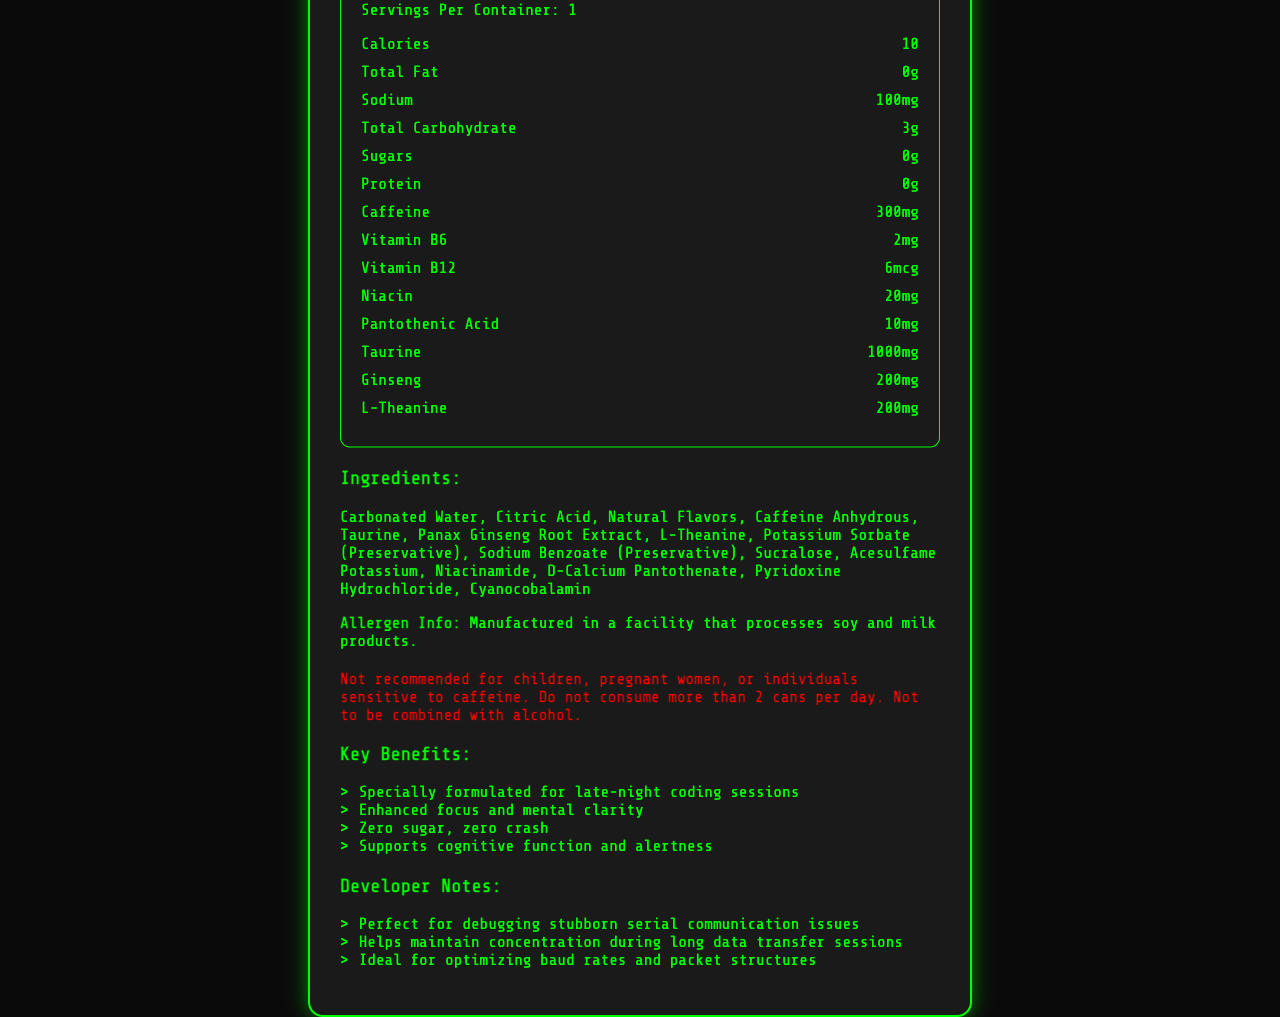what is the serving size for CodeBlast Extreme? The serving size is explicitly mentioned as "16 fl oz (473 mL)" in the document under Nutrition Facts.
Answer: 16 fl oz (473 mL) how many calories are there per serving? The document lists "Calories" as 10 per serving in the Nutrition Facts section.
Answer: 10 How much caffeine does one serving of CodeBlast Extreme contain? The document indicates that each serving contains 300mg of caffeine.
Answer: 300mg what are the ingredients listed in CodeBlast Extreme? The document includes a section titled "Ingredients" which lists all the ingredients.
Answer: Carbonated Water, Citric Acid, Natural Flavors, Caffeine Anhydrous, Taurine, Panax Ginseng Root Extract, L-Theanine, Potassium Sorbate (Preservative), Sodium Benzoate (Preservative), Sucralose, Acesulfame Potassium, Niacinamide, D-Calcium Pantothenate, Pyridoxine Hydrochloride, Cyanocobalamin what is the warning statement on the CodeBlast Extreme label? The warning statement is clearly mentioned towards the end of the document.
Answer: Not recommended for children, pregnant women, or individuals sensitive to caffeine. Do not consume more than 2 cans per day. Not to be combined with alcohol which vitamin is present in the highest amount in CodeBlast Extreme? 
A. Vitamin B6
B. Vitamin B12
C. Niacin
D. Pantothenic Acid The document lists Niacin at 20mg, which is more than the amounts of Vitamin B6 (2mg), Vitamin B12 (6mcg), and Pantothenic Acid (10mg).
Answer: C. Niacin how much sodium does one serving of CodeBlast Extreme contain?
1. 50mg
2. 100mg
3. 150mg
4. 200mg The document lists sodium content as 100mg per serving under the Nutrition Facts section.
Answer: 2. 100mg is CodeBlast Extreme recommended for children? The warning statement on the document explicitly says "Not recommended for children."
Answer: No which of these benefits is not mentioned in the marketing claims?
1. Enhanced focus and mental clarity
2. Zero sugar, zero crash
3. Supports athletic performance
4. Supports cognitive function and alertness The listed marketing claims include enhanced focus, zero sugar, and supports cognitive function but do not mention athletic performance.
Answer: 3. Supports athletic performance summarize the main idea of the document. The document primarily advertises the benefits, nutritional content, and safety information for CodeBlast Extreme, stressing its effectiveness for late-night coding and mental alertness.
Answer: CodeBlast Extreme is a high-caffeine energy drink specially formulated for late-night coding sessions, featuring various vitamins and cognitive enhancers, and includes warnings about usage limits and allergen information. what is the exact amount of taurine in CodeBlast Extreme? The Nutrition Facts section mentions that one serving contains 1000mg of taurine.
Answer: 1000mg can the facility where CodeBlast Extreme is made handle gluten products? The allergen information only mentions soy and milk products but doesn't provide details about gluten.
Answer: Cannot be determined 